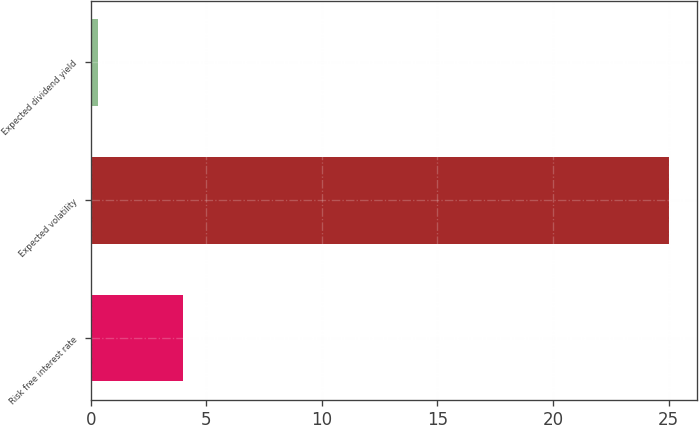Convert chart. <chart><loc_0><loc_0><loc_500><loc_500><bar_chart><fcel>Risk free interest rate<fcel>Expected volatility<fcel>Expected dividend yield<nl><fcel>4<fcel>25<fcel>0.3<nl></chart> 